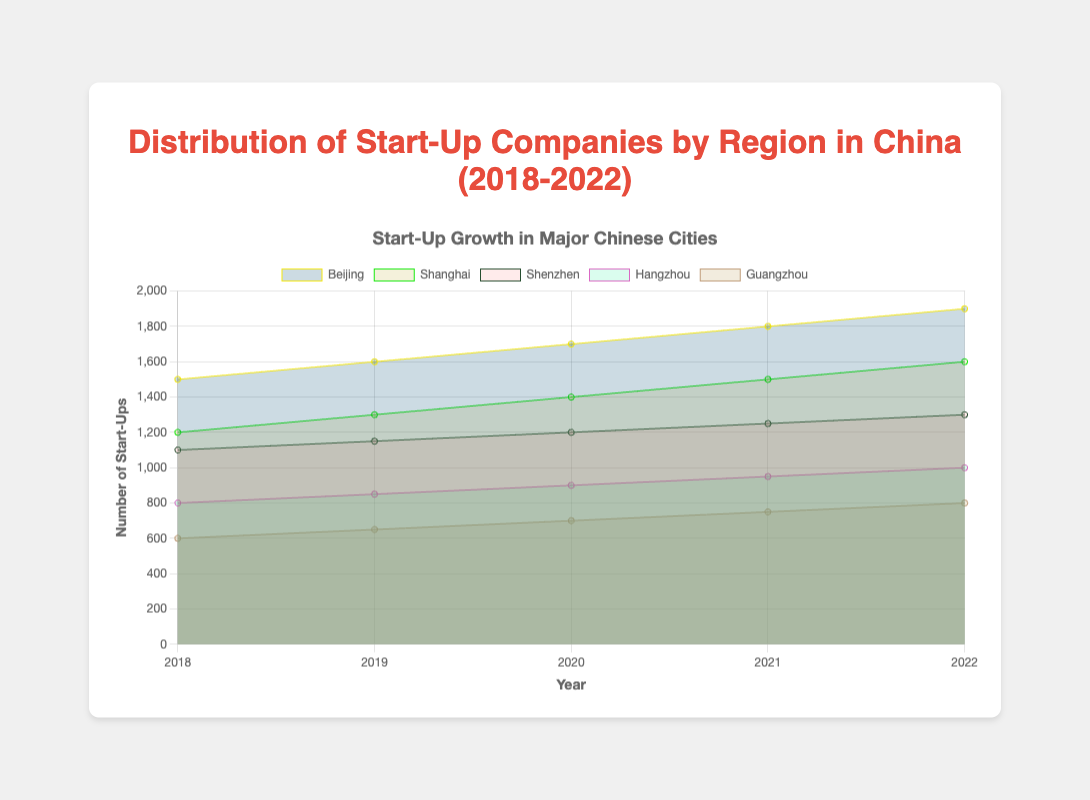How many start-ups were there in Beijing in 2018? Refer to the area representing Beijing's start-ups for the year 2018. The number is labeled as 1500.
Answer: 1500 Which city had the most start-ups in 2022? Compare the areas of all cities in 2022. The largest area belongs to Beijing.
Answer: Beijing How did the number of start-ups in Hangzhou change from 2018 to 2022? Subtract the number of start-ups in 2018 (800) from the number in 2022 (1000). The increase is 1000 - 800 = 200.
Answer: Increased by 200 What is the title of the chart? Look at the top of the figure where the title is displayed. It reads "Distribution of Start-Up Companies by Region in China (2018-2022)".
Answer: Distribution of Start-Up Companies by Region in China (2018-2022) Which city showed the smallest growth in start-ups over the years? Compare the growth for each city from 2018 to 2022. Guangzhou's start-ups grew from 600 to 800, the smallest absolute growth (200).
Answer: Guangzhou Between which consecutive years did Beijing see the largest increase in start-ups? Calculate the increase for each year-to-year jump in Beijing: 1600-1500 (100), 1700-1600 (100), 1800-1700 (100), 1900-1800 (100). All increases are equal.
Answer: 2021 to 2022 (also 2018-2019, 2019-2020, 2020-2021) What is the relative position of Shanghai's start-ups compared to Shenzhen's in 2020? Compare the areas for Shanghai and Shenzhen in 2020. Shanghai has 1400, while Shenzhen has 1200 start-ups.
Answer: Higher How many total start-ups were there across all regions in 2019? Sum the start-ups for each region in 2019: 1600 (Beijing) + 1300 (Shanghai) + 1150 (Shenzhen) + 850 (Hangzhou) + 650 (Guangzhou). Total = 5550.
Answer: 5550 Which two regions had the closest number of start-ups in 2021, and what are those numbers? Compare the numbers in 2021 and find the closest pair. Hangzhou (950) and Guangzhou (750) are closest with a difference of 200.
Answer: Hangzhou: 950, Guangzhou: 750 